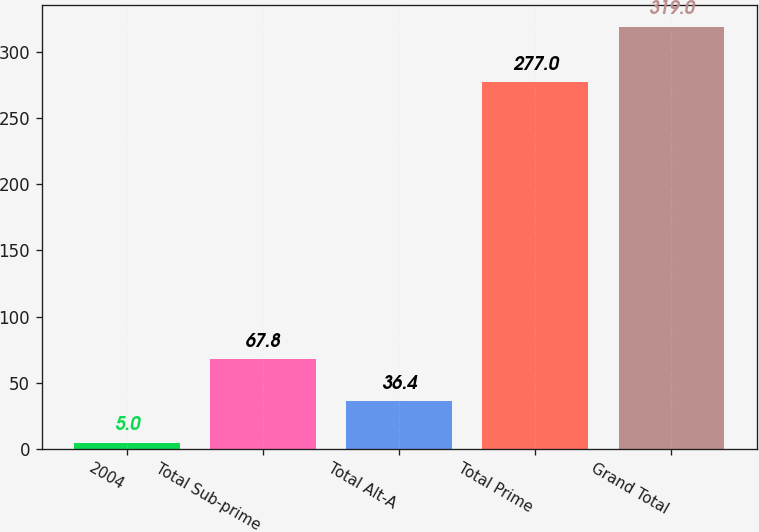Convert chart to OTSL. <chart><loc_0><loc_0><loc_500><loc_500><bar_chart><fcel>2004<fcel>Total Sub-prime<fcel>Total Alt-A<fcel>Total Prime<fcel>Grand Total<nl><fcel>5<fcel>67.8<fcel>36.4<fcel>277<fcel>319<nl></chart> 